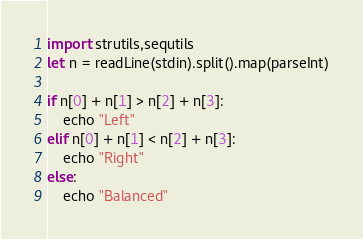<code> <loc_0><loc_0><loc_500><loc_500><_Nim_>import strutils,sequtils
let n = readLine(stdin).split().map(parseInt)

if n[0] + n[1] > n[2] + n[3]:
    echo "Left"
elif n[0] + n[1] < n[2] + n[3]:
    echo "Right"
else:
    echo "Balanced"</code> 